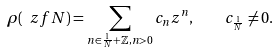Convert formula to latex. <formula><loc_0><loc_0><loc_500><loc_500>\rho ( \ z f { N } ) = \sum _ { n \in \frac { 1 } { N } + \mathbb { Z } , n > 0 } c _ { n } z ^ { n } , \quad c _ { \frac { 1 } { N } } \ne 0 .</formula> 